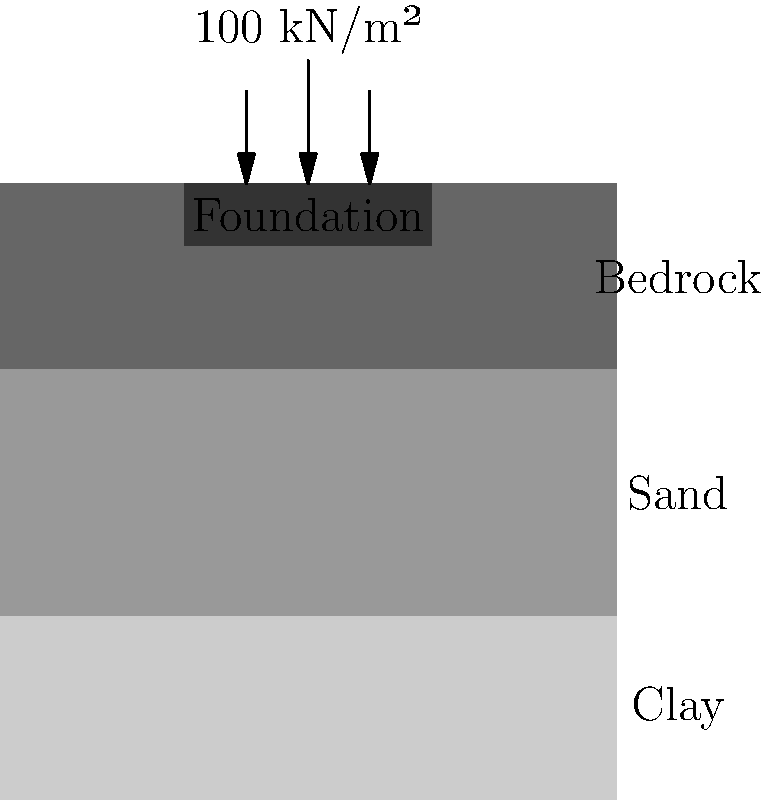Given the soil profile and foundation load shown in the diagram, estimate the total settlement of the building foundation. The clay layer has a thickness of 30 cm and a compression index (Cc) of 0.2, while its initial void ratio (e0) is 0.8 and its pre-consolidation pressure (pc) is 80 kN/m². The sand and bedrock layers can be considered incompressible. How would you approach this problem as if explaining it to your younger sibling who's interested in becoming a goalkeeper? Alright, let's break this down step-by-step, just like we would analyze a goalkeeper's positioning for a corner kick:

1) First, we need to identify the layer that will contribute most to the settlement. In this case, it's the clay layer, as sand and bedrock are considered incompressible.

2) We'll use the consolidation settlement equation for the clay layer:
   $$S = \frac{C_c H}{1 + e_0} \log_{10}\left(\frac{p_0 + \Delta p}{p_0}\right)$$
   where:
   $S$ = settlement
   $C_c$ = compression index
   $H$ = thickness of clay layer
   $e_0$ = initial void ratio
   $p_0$ = initial effective stress at the middle of the clay layer
   $\Delta p$ = change in stress due to the foundation load

3) Calculate $p_0$:
   $p_0 = \gamma_{clay} \times \frac{H}{2} = 18 \text{ kN/m³} \times 0.15 \text{ m} = 2.7 \text{ kN/m²}$

4) The change in stress $\Delta p$ is the foundation load: 100 kN/m²

5) Now, let's plug everything into our equation:
   $$S = \frac{0.2 \times 0.3 \text{ m}}{1 + 0.8} \log_{10}\left(\frac{2.7 \text{ kN/m²} + 100 \text{ kN/m²}}{2.7 \text{ kN/m²}}\right)$$

6) Simplify and calculate:
   $$S = 0.0333 \times \log_{10}(38.04) = 0.0333 \times 1.58 = 0.0526 \text{ m} = 5.26 \text{ cm}$$

Just like in goalkeeping, where every centimeter matters when diving for a save, in foundation engineering, even small settlements can be significant!
Answer: 5.26 cm 